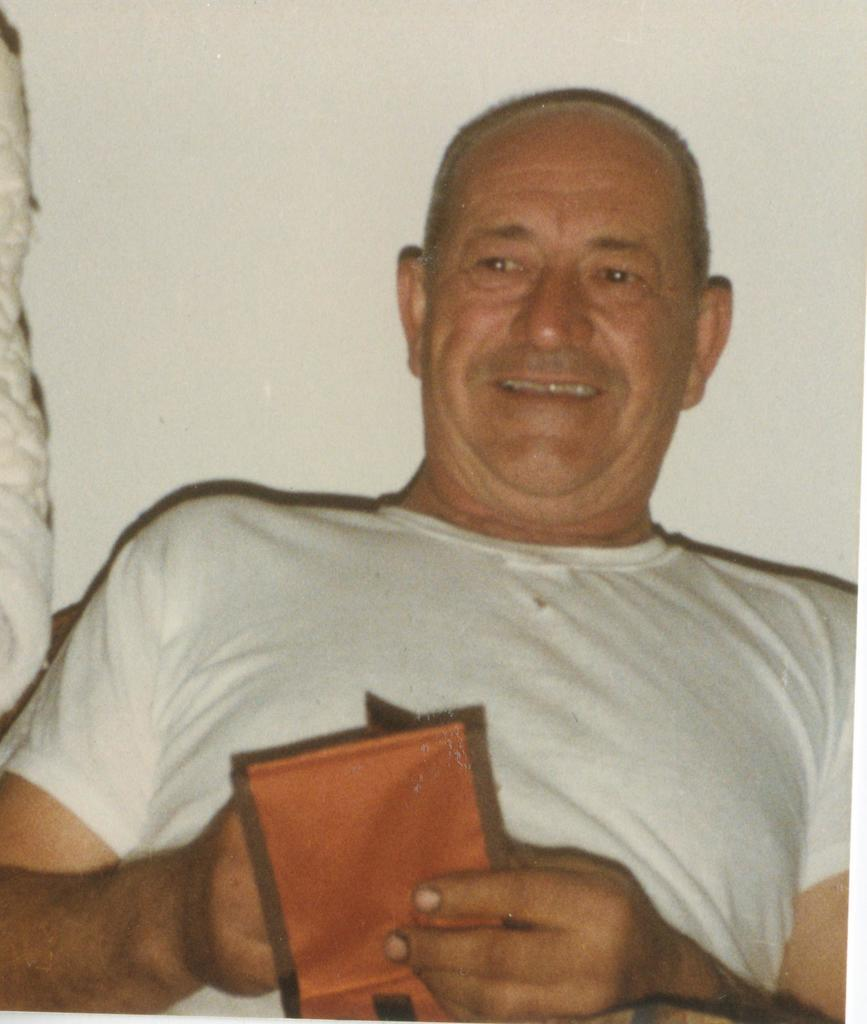What is the main subject of the picture? The main subject of the picture is a man. What is the man holding in the picture? The man is holding a wallet. What can be seen behind the man in the picture? There is a wall visible behind the man. How many trains can be seen in the picture? There are no trains visible in the picture; it features a man holding a wallet with a wall in the background. What type of skin condition does the man have in the picture? There is no indication of any skin condition in the picture; it only shows a man holding a wallet with a wall in the background. 